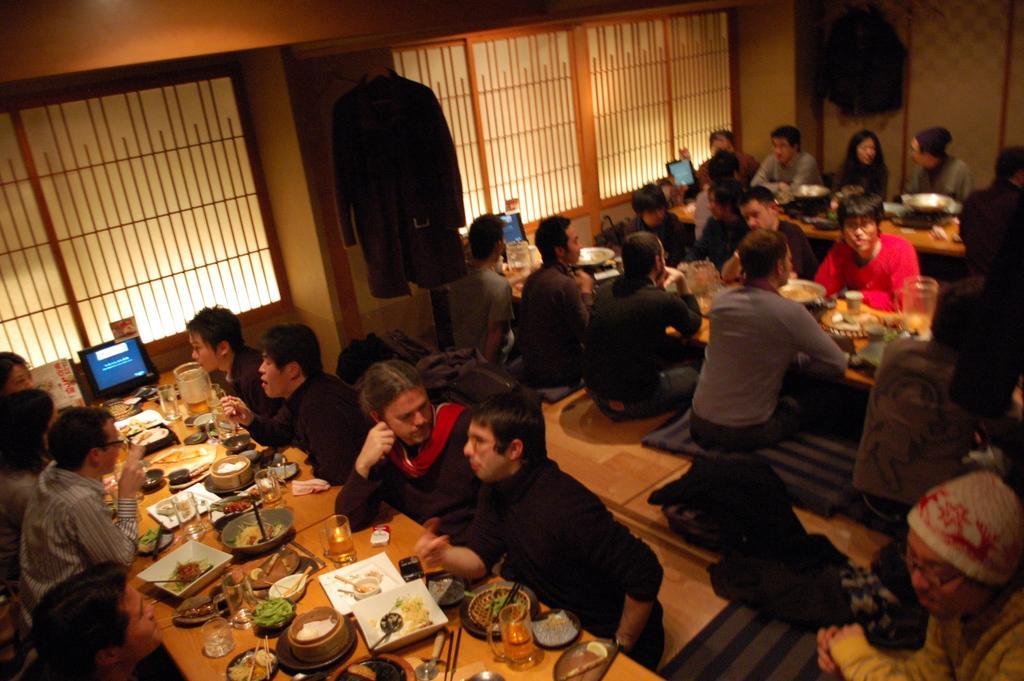Could you give a brief overview of what you see in this image? In this picture we can see a group of people sitting on chairs and in front of them on table we have bowls, spoons, glasses, some dishes, chop sticks, laptops, jar with drink in it and in background we can see wall, coat hanger to hanger. 